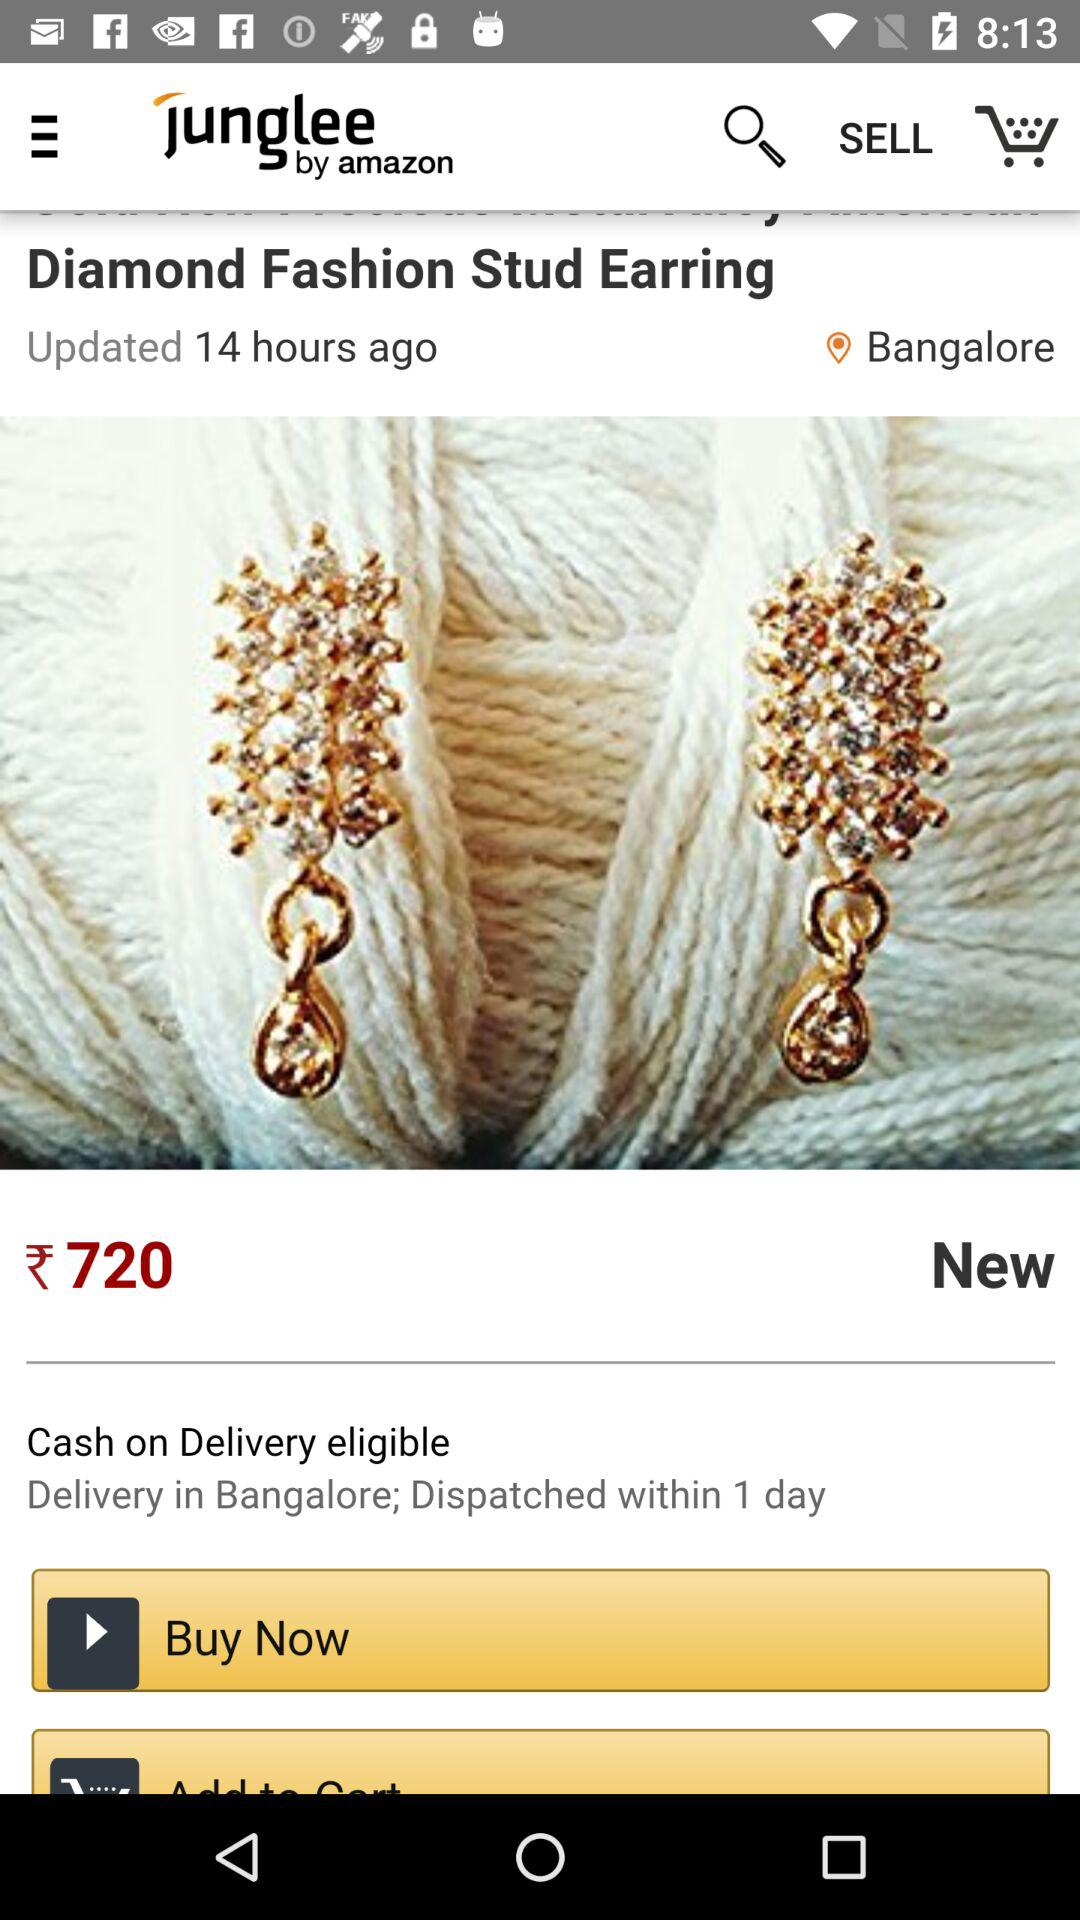When was the product post last updated? The product post was last updated 14 hours ago. 